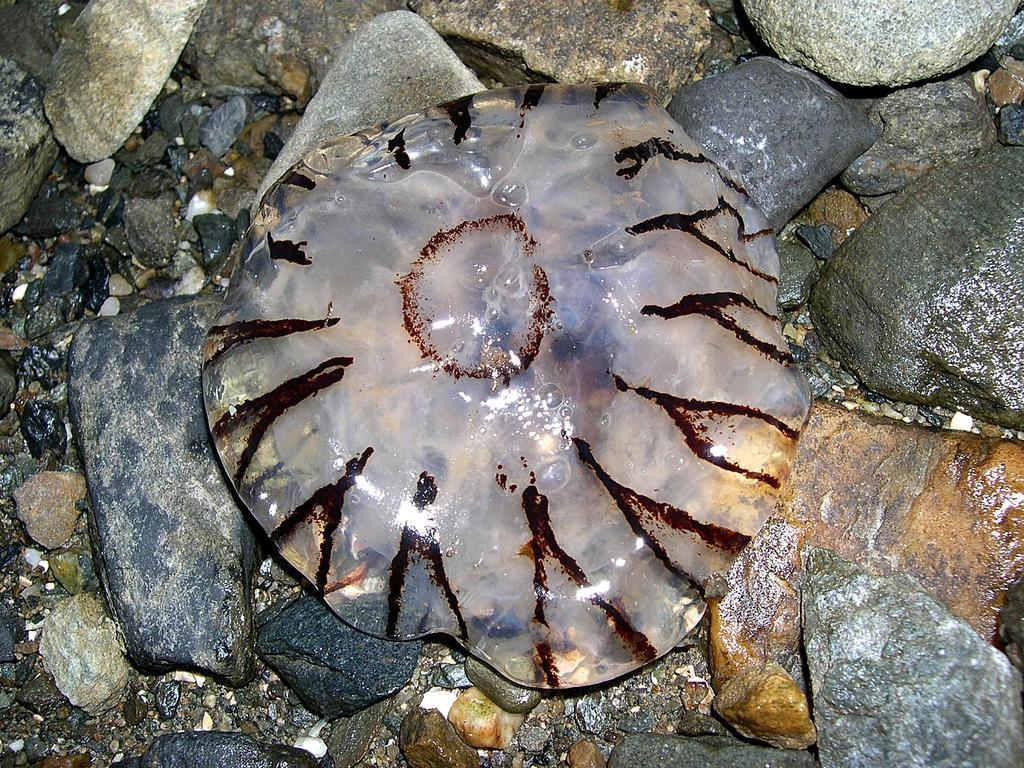In one or two sentences, can you explain what this image depicts? In this image there is some liquid inside a plastic cover. On the ground there are cobblestones. 